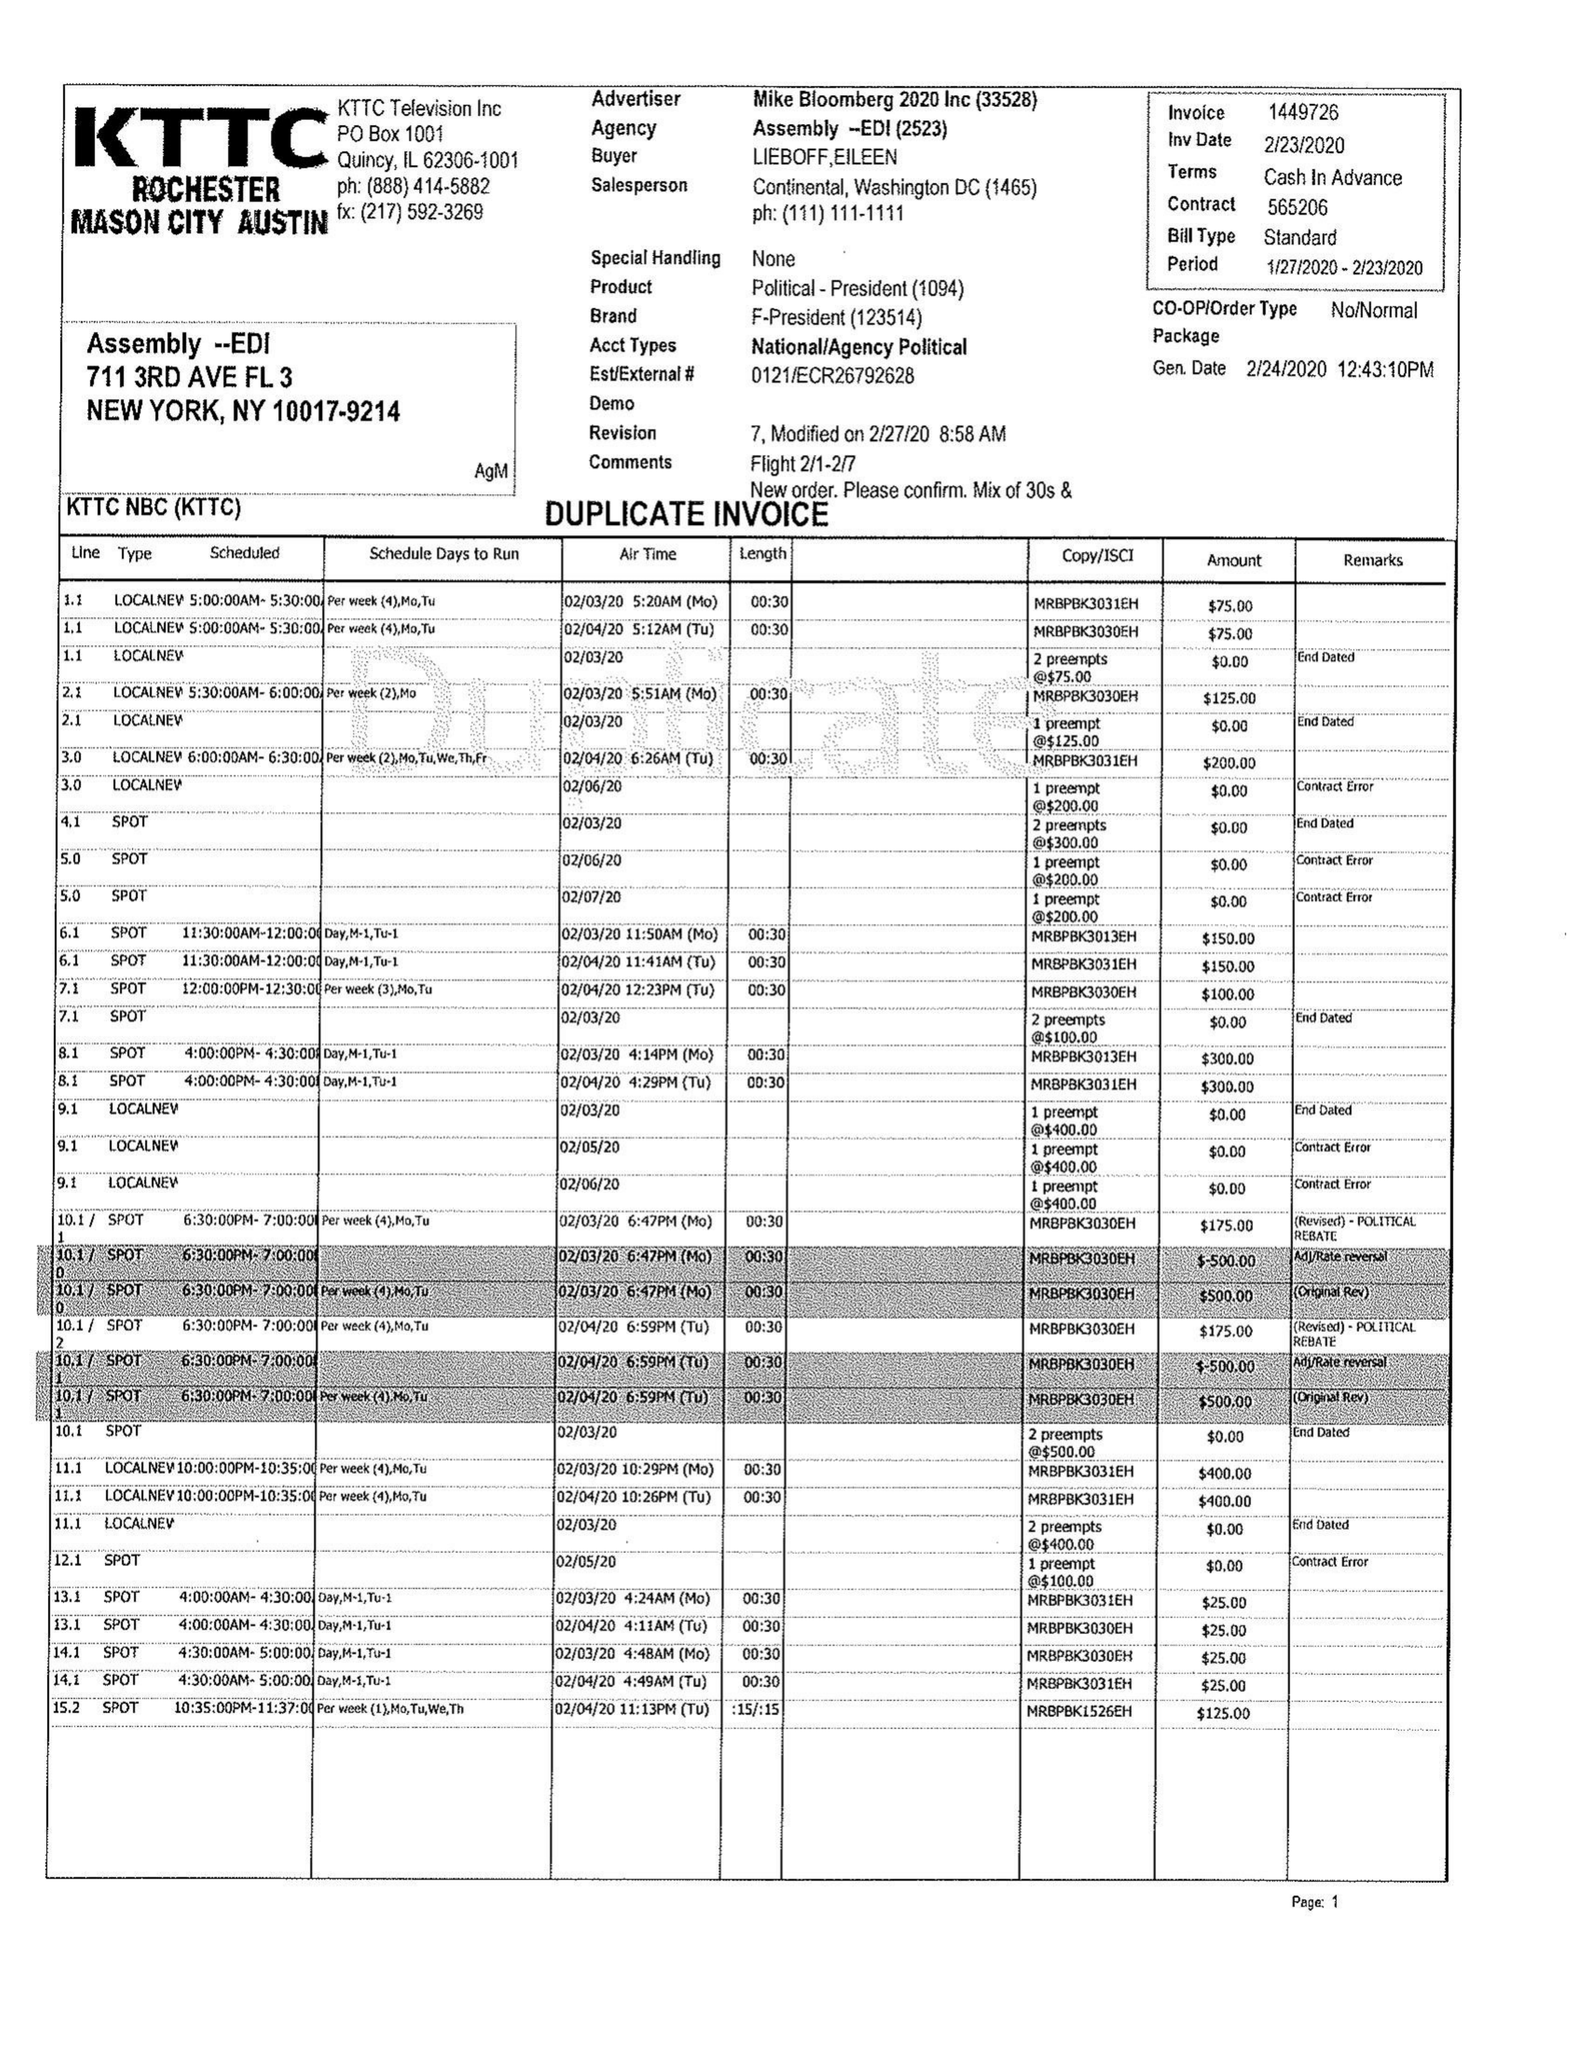What is the value for the advertiser?
Answer the question using a single word or phrase. MIKE BLOOMBERG 2020 INC 